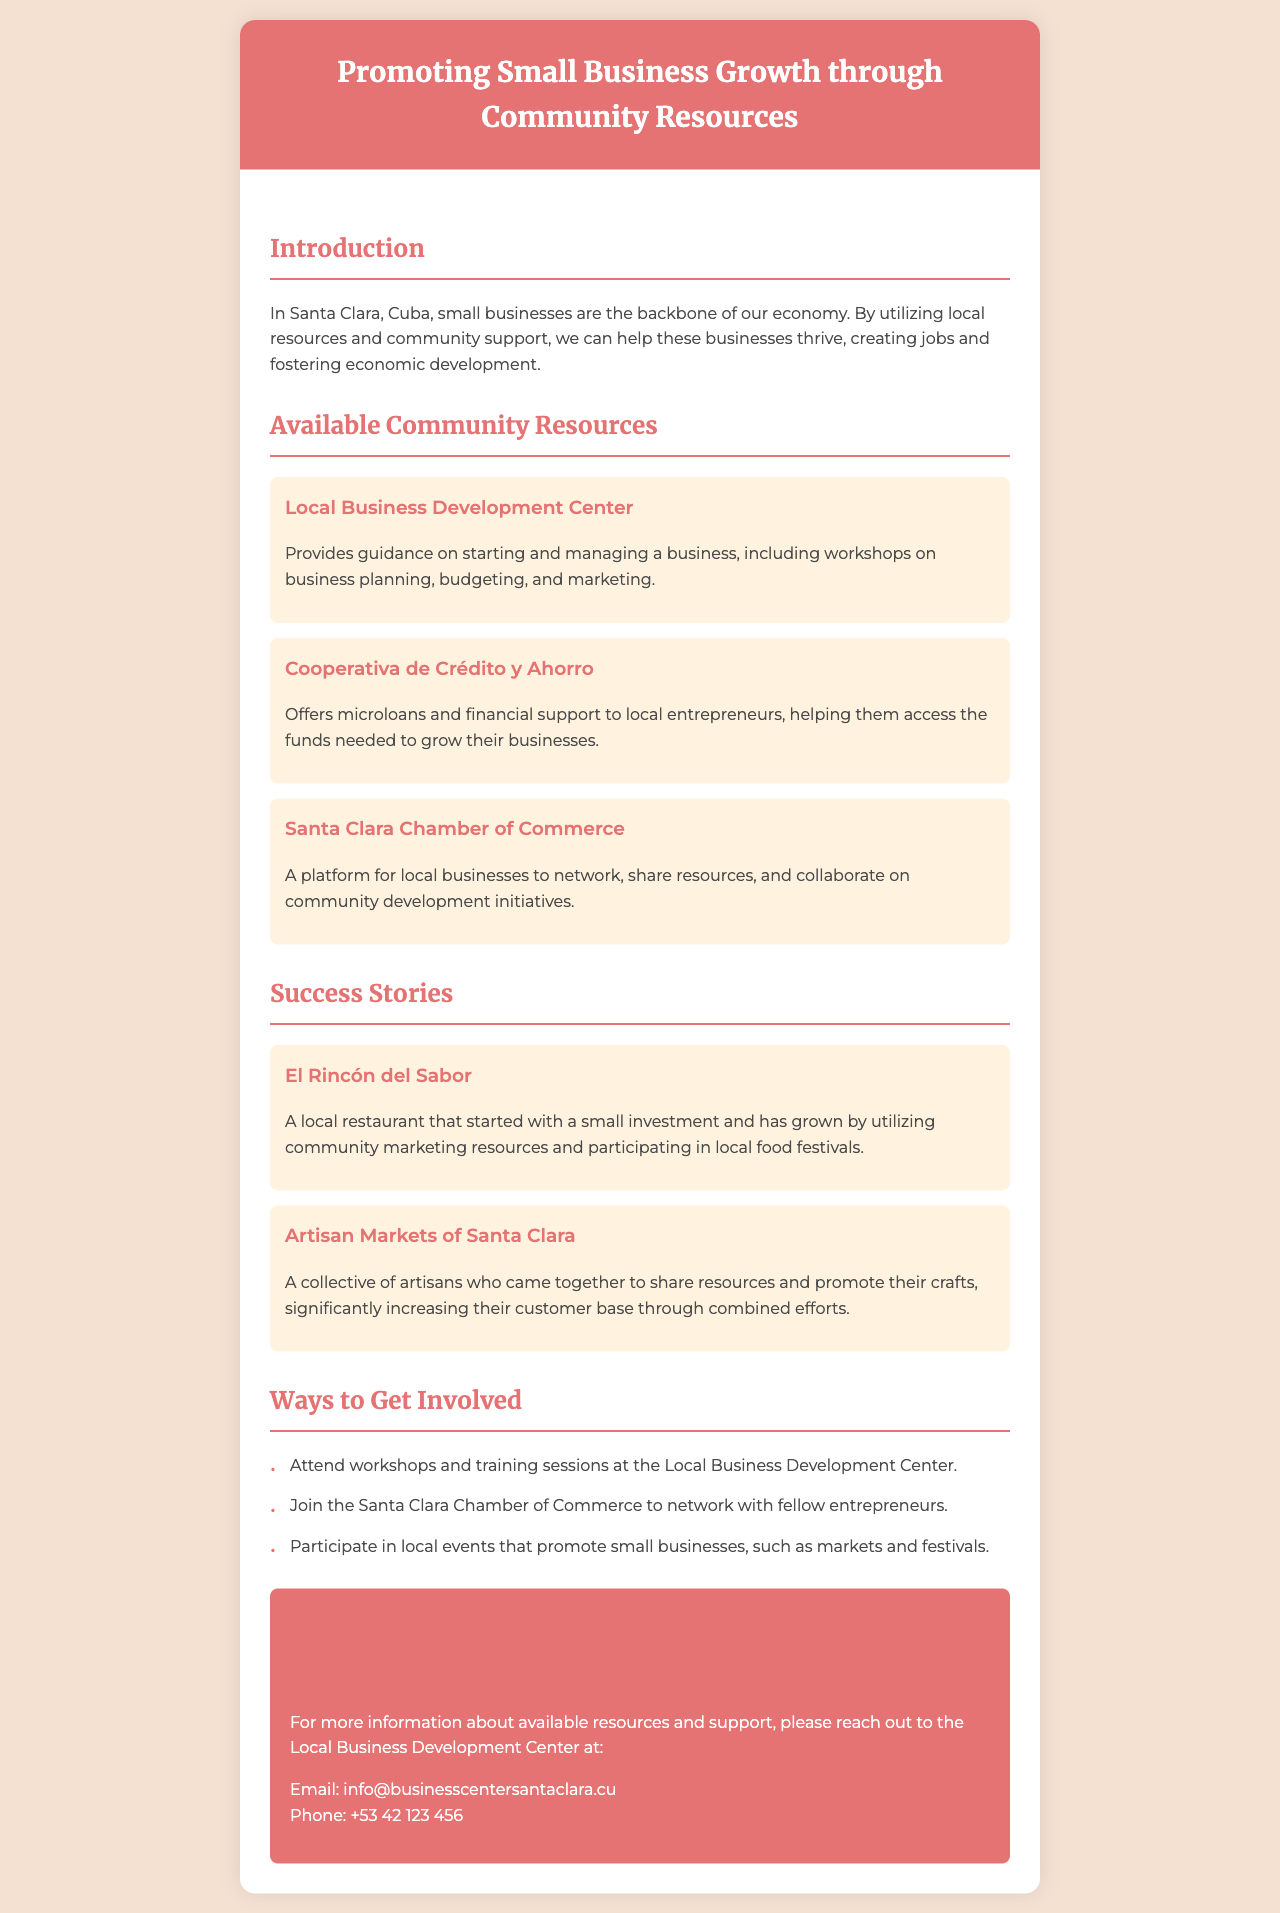What is the title of the brochure? The title of the brochure is indicated prominently at the top of the document.
Answer: Promoting Small Business Growth through Community Resources What organization provides workshops on business planning? The brochure lists a specific organization that offers guidance and workshops for local entrepreneurs.
Answer: Local Business Development Center What type of support does Cooperativa de Crédito y Ahorro offer? The brochure describes the support provided by this financial institution to help local entrepreneurs.
Answer: Microloans What is one of the success stories mentioned? The document highlights specific examples of businesses that have successfully utilized community resources.
Answer: El Rincón del Sabor How can individuals get involved according to the brochure? The brochure outlines specific actions that individuals can take to engage with local small businesses and resources.
Answer: Attend workshops What color is used for the header section? The header section of the brochure is described in terms of its color in the document.
Answer: e57373 Which phone number can be used to contact the Local Business Development Center? The brochure provides contact information, specifically a phone number for inquiries.
Answer: +53 42 123 456 What community event can help artisans increase their customer base? The document provides information about community initiatives that promote collaboration among local artisans.
Answer: Artisan Markets What is the main goal of the brochure as stated in the introduction? The introduction of the brochure outlines the primary objective related to small businesses in Santa Clara.
Answer: Help these businesses thrive 